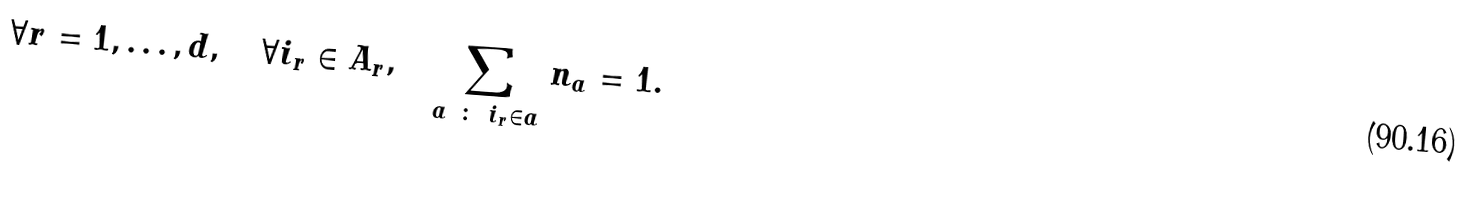<formula> <loc_0><loc_0><loc_500><loc_500>\forall r = 1 , \dots , d , \quad \forall i _ { r } \in A _ { r } , \quad \sum _ { a \ \colon \ i _ { r } \in a } n _ { a } = 1 .</formula> 